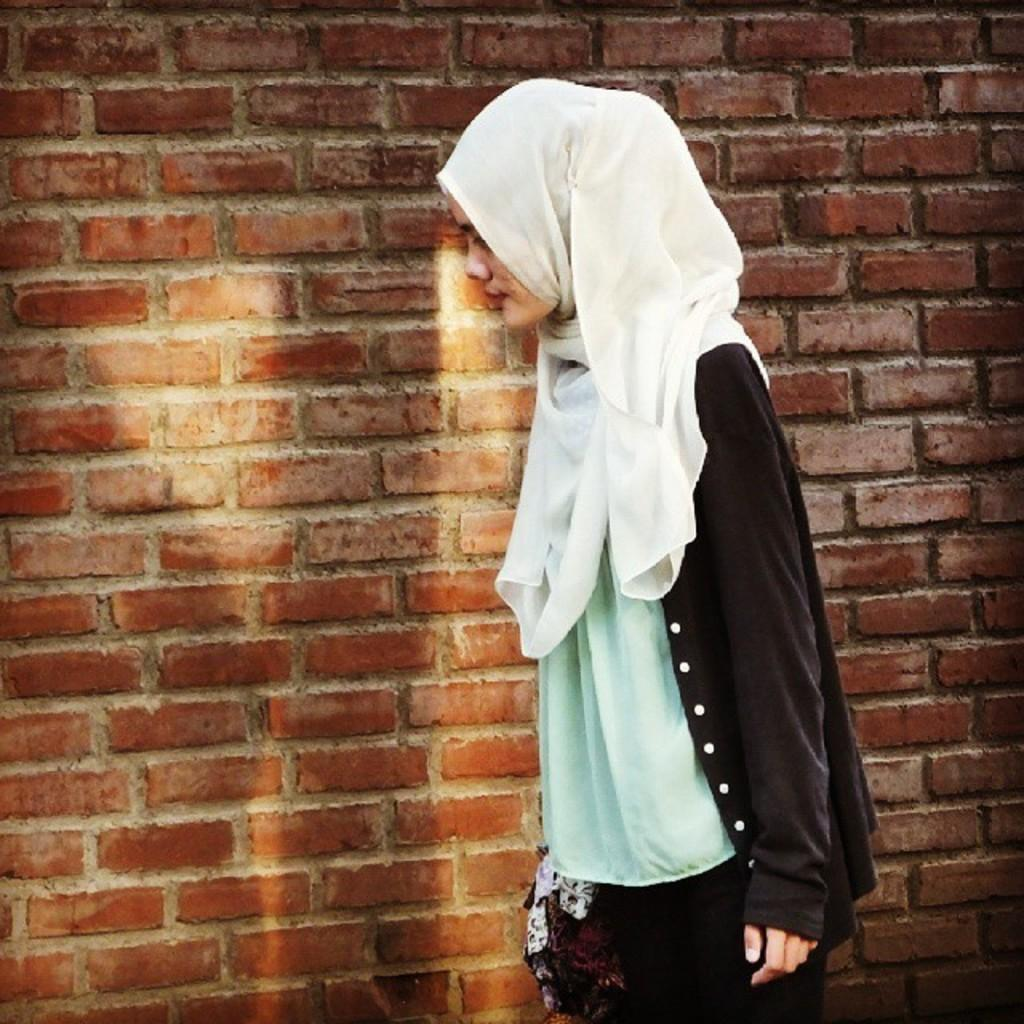What is the main subject in the foreground of the picture? There is a woman in the foreground of the picture. What is the woman doing in the image? The woman is walking. What can be seen in the background of the image? There is a brick wall in the background of the image. What type of lipstick is the woman wearing in the image? There is no indication of the woman wearing lipstick or any makeup in the image. 